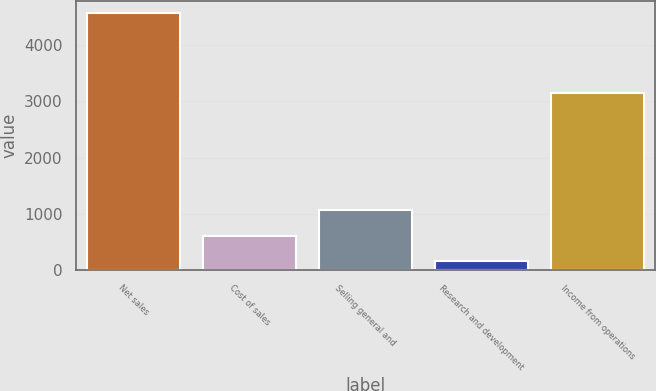Convert chart. <chart><loc_0><loc_0><loc_500><loc_500><bar_chart><fcel>Net sales<fcel>Cost of sales<fcel>Selling general and<fcel>Research and development<fcel>Income from operations<nl><fcel>4561<fcel>607.3<fcel>1062<fcel>168<fcel>3155<nl></chart> 